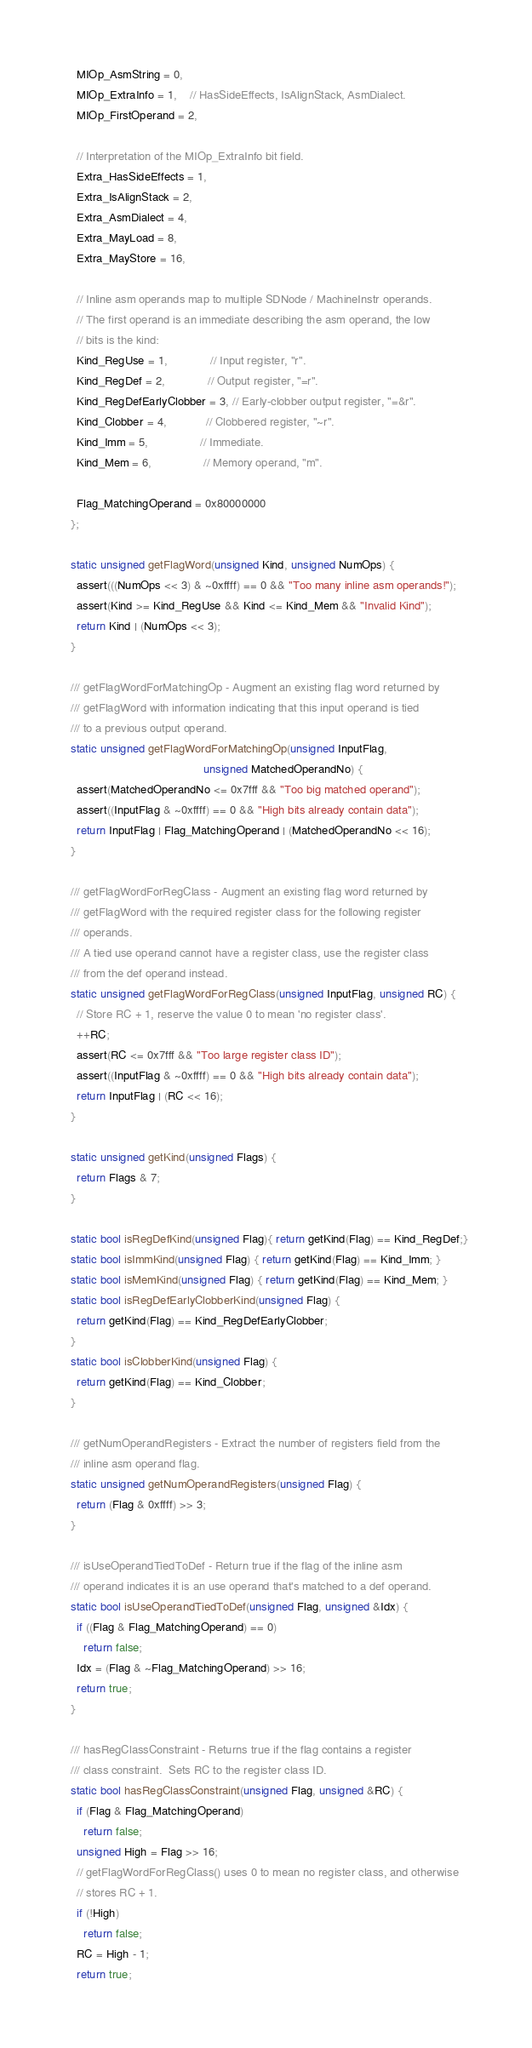<code> <loc_0><loc_0><loc_500><loc_500><_C_>    MIOp_AsmString = 0,
    MIOp_ExtraInfo = 1,    // HasSideEffects, IsAlignStack, AsmDialect.
    MIOp_FirstOperand = 2,

    // Interpretation of the MIOp_ExtraInfo bit field.
    Extra_HasSideEffects = 1,
    Extra_IsAlignStack = 2,
    Extra_AsmDialect = 4,
    Extra_MayLoad = 8,
    Extra_MayStore = 16,

    // Inline asm operands map to multiple SDNode / MachineInstr operands.
    // The first operand is an immediate describing the asm operand, the low
    // bits is the kind:
    Kind_RegUse = 1,             // Input register, "r".
    Kind_RegDef = 2,             // Output register, "=r".
    Kind_RegDefEarlyClobber = 3, // Early-clobber output register, "=&r".
    Kind_Clobber = 4,            // Clobbered register, "~r".
    Kind_Imm = 5,                // Immediate.
    Kind_Mem = 6,                // Memory operand, "m".

    Flag_MatchingOperand = 0x80000000
  };
  
  static unsigned getFlagWord(unsigned Kind, unsigned NumOps) {
    assert(((NumOps << 3) & ~0xffff) == 0 && "Too many inline asm operands!");
    assert(Kind >= Kind_RegUse && Kind <= Kind_Mem && "Invalid Kind");
    return Kind | (NumOps << 3);
  }
  
  /// getFlagWordForMatchingOp - Augment an existing flag word returned by
  /// getFlagWord with information indicating that this input operand is tied 
  /// to a previous output operand.
  static unsigned getFlagWordForMatchingOp(unsigned InputFlag,
                                           unsigned MatchedOperandNo) {
    assert(MatchedOperandNo <= 0x7fff && "Too big matched operand");
    assert((InputFlag & ~0xffff) == 0 && "High bits already contain data");
    return InputFlag | Flag_MatchingOperand | (MatchedOperandNo << 16);
  }

  /// getFlagWordForRegClass - Augment an existing flag word returned by
  /// getFlagWord with the required register class for the following register
  /// operands.
  /// A tied use operand cannot have a register class, use the register class
  /// from the def operand instead.
  static unsigned getFlagWordForRegClass(unsigned InputFlag, unsigned RC) {
    // Store RC + 1, reserve the value 0 to mean 'no register class'.
    ++RC;
    assert(RC <= 0x7fff && "Too large register class ID");
    assert((InputFlag & ~0xffff) == 0 && "High bits already contain data");
    return InputFlag | (RC << 16);
  }

  static unsigned getKind(unsigned Flags) {
    return Flags & 7;
  }

  static bool isRegDefKind(unsigned Flag){ return getKind(Flag) == Kind_RegDef;}
  static bool isImmKind(unsigned Flag) { return getKind(Flag) == Kind_Imm; }
  static bool isMemKind(unsigned Flag) { return getKind(Flag) == Kind_Mem; }
  static bool isRegDefEarlyClobberKind(unsigned Flag) {
    return getKind(Flag) == Kind_RegDefEarlyClobber;
  }
  static bool isClobberKind(unsigned Flag) {
    return getKind(Flag) == Kind_Clobber;
  }

  /// getNumOperandRegisters - Extract the number of registers field from the
  /// inline asm operand flag.
  static unsigned getNumOperandRegisters(unsigned Flag) {
    return (Flag & 0xffff) >> 3;
  }

  /// isUseOperandTiedToDef - Return true if the flag of the inline asm
  /// operand indicates it is an use operand that's matched to a def operand.
  static bool isUseOperandTiedToDef(unsigned Flag, unsigned &Idx) {
    if ((Flag & Flag_MatchingOperand) == 0)
      return false;
    Idx = (Flag & ~Flag_MatchingOperand) >> 16;
    return true;
  }

  /// hasRegClassConstraint - Returns true if the flag contains a register
  /// class constraint.  Sets RC to the register class ID.
  static bool hasRegClassConstraint(unsigned Flag, unsigned &RC) {
    if (Flag & Flag_MatchingOperand)
      return false;
    unsigned High = Flag >> 16;
    // getFlagWordForRegClass() uses 0 to mean no register class, and otherwise
    // stores RC + 1.
    if (!High)
      return false;
    RC = High - 1;
    return true;</code> 